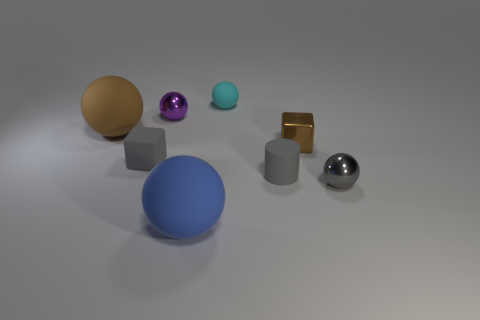There is a tiny gray matte object that is behind the gray matte cylinder; are there any small cyan balls that are on the left side of it?
Make the answer very short. No. What number of large things are either green cylinders or gray metallic spheres?
Make the answer very short. 0. Are there any purple cylinders that have the same size as the rubber block?
Your answer should be compact. No. What number of metallic objects are gray blocks or small gray things?
Your response must be concise. 1. There is a metal object that is the same color as the rubber cube; what is its shape?
Provide a short and direct response. Sphere. What number of large green rubber spheres are there?
Your answer should be compact. 0. Do the brown object on the left side of the small purple sphere and the big object that is on the right side of the large brown thing have the same material?
Your answer should be compact. Yes. What size is the brown thing that is made of the same material as the cyan object?
Give a very brief answer. Large. There is a gray matte thing that is to the left of the small purple metallic ball; what is its shape?
Offer a terse response. Cube. There is a small metal object left of the big blue rubber object; is it the same color as the large sphere that is to the left of the small gray rubber block?
Make the answer very short. No. 